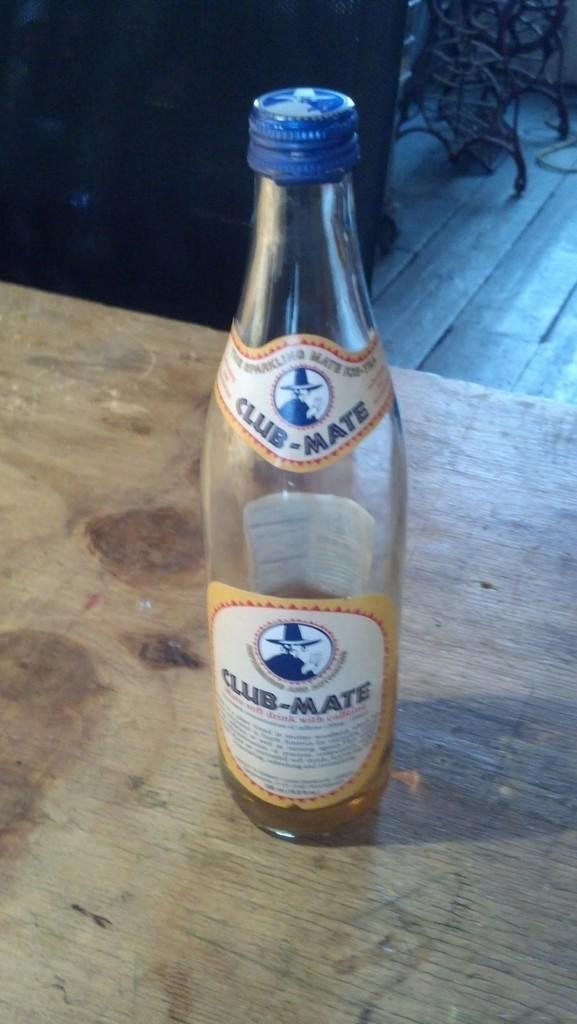Provide a one-sentence caption for the provided image. A bottle of club-mate resting in a table. 